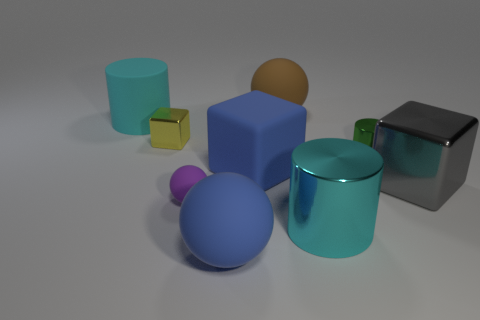Add 1 yellow metallic objects. How many objects exist? 10 Subtract all cylinders. How many objects are left? 6 Subtract all tiny red metal things. Subtract all large blue things. How many objects are left? 7 Add 2 purple spheres. How many purple spheres are left? 3 Add 8 large yellow rubber blocks. How many large yellow rubber blocks exist? 8 Subtract 0 purple cylinders. How many objects are left? 9 